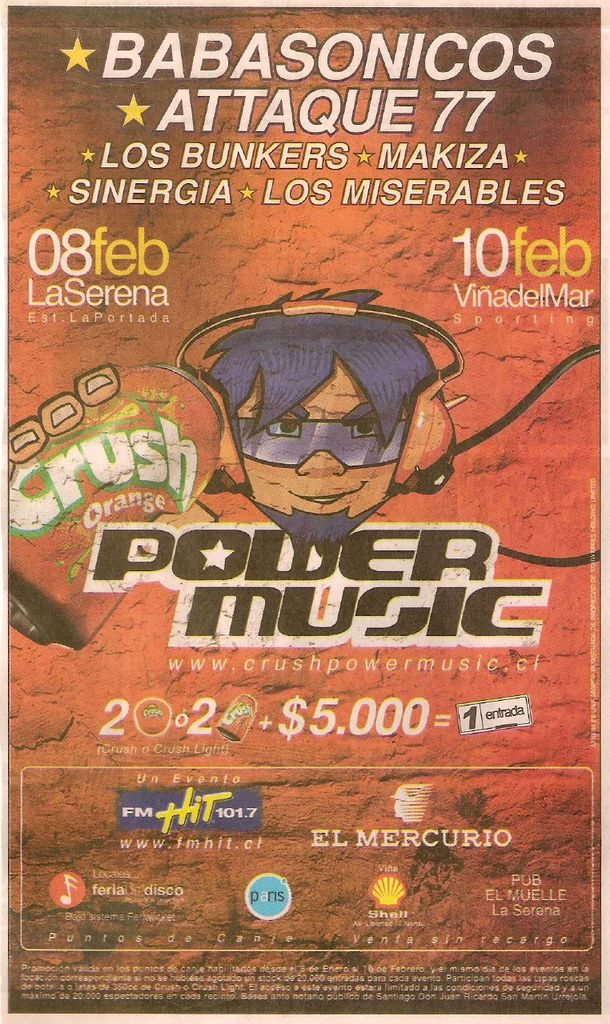Provide a one-sentence caption for the provided image. The image is a promotional poster for the Crush Power Music festival featuring performances by Babasonicos, Attaque 77, and other bands on February 8th and 10th in La Serena and Vina del Mar. 